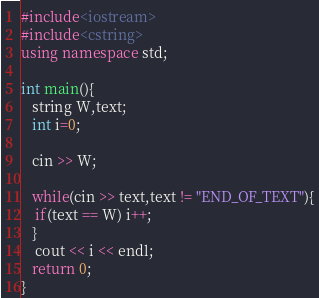<code> <loc_0><loc_0><loc_500><loc_500><_C++_>#include<iostream>
#include<cstring>
using namespace std;

int main(){
   string W,text;
   int i=0;

   cin >> W;

   while(cin >> text,text != "END_OF_TEXT"){
	if(text == W) i++;
   }
	cout << i << endl;
   return 0;
}</code> 